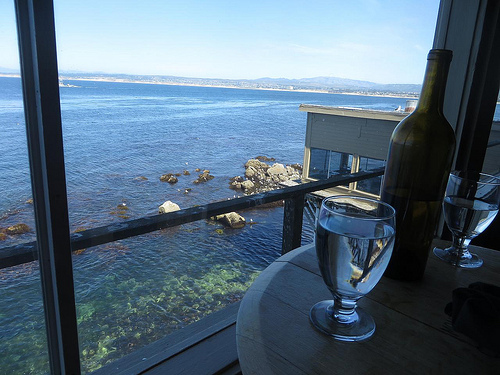<image>
Can you confirm if the glass is under the window? No. The glass is not positioned under the window. The vertical relationship between these objects is different. Is the sky behind the glass? Yes. From this viewpoint, the sky is positioned behind the glass, with the glass partially or fully occluding the sky. Where is the water in relation to the water? Is it in front of the water? Yes. The water is positioned in front of the water, appearing closer to the camera viewpoint. 